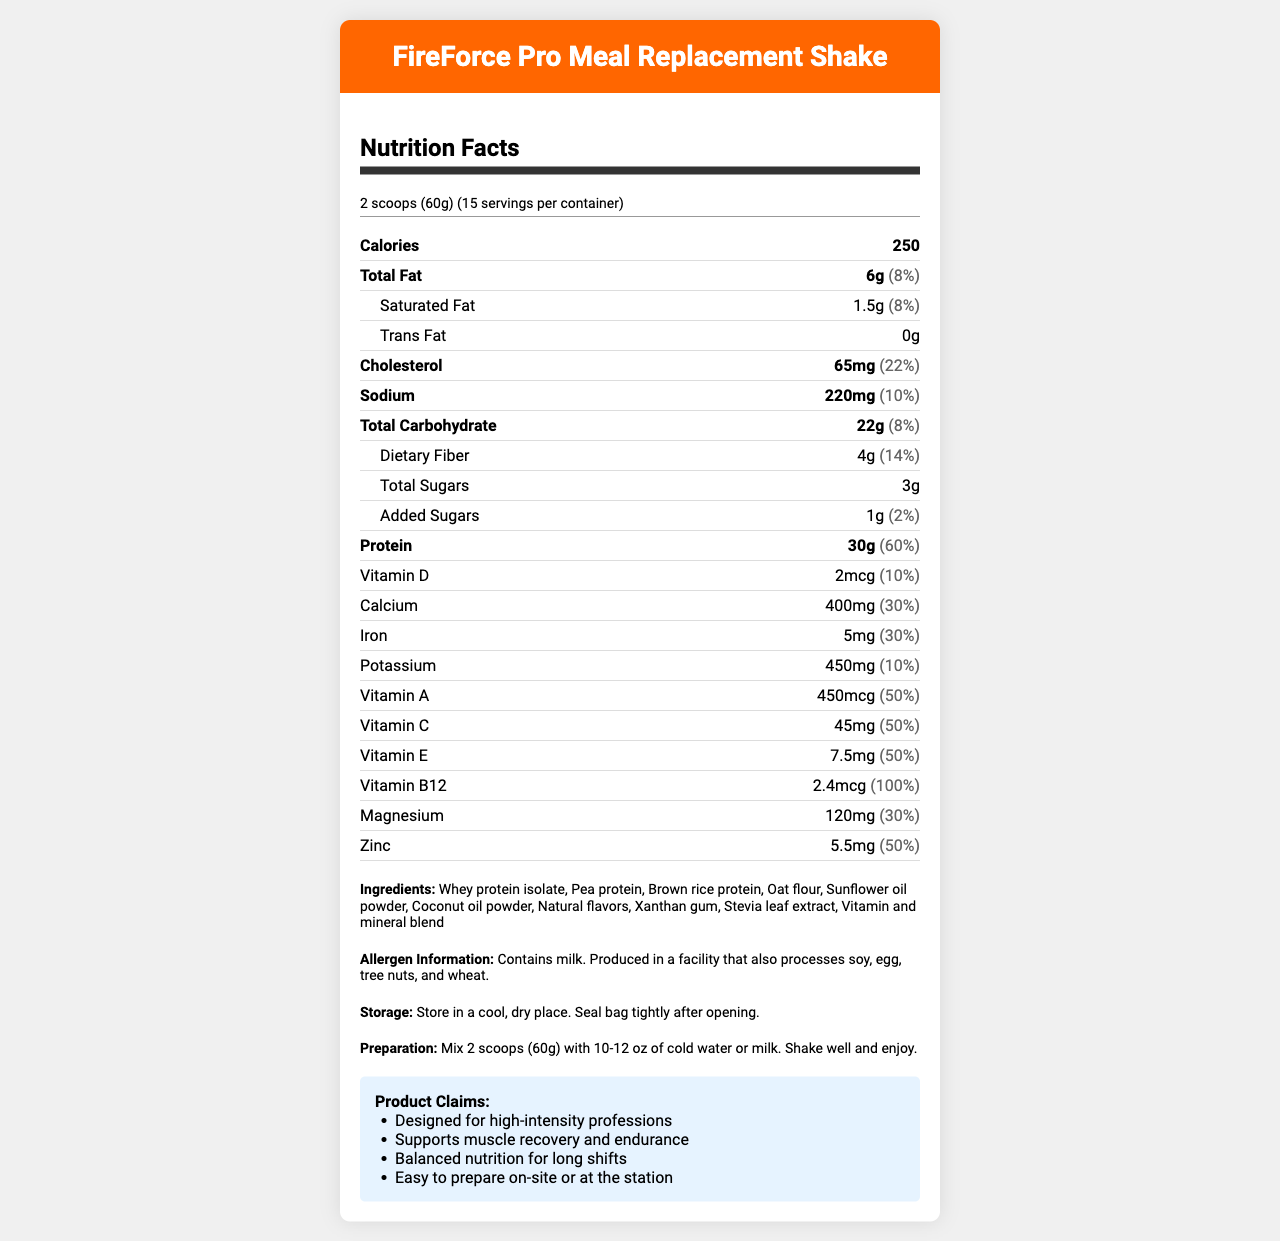What is the product name? The product name is stated at the top of the document, in the header.
Answer: FireForce Pro Meal Replacement Shake What is the serving size for FireForce Pro Meal Replacement Shake? The serving size information is provided under "Nutrition Facts."
Answer: 2 scoops (60g) How many calories are there per serving? The calories per serving are listed in the "Nutrition Facts" section.
Answer: 250 What is the amount of protein per serving? Protein amount is detailed in the "Nutrition Facts" section.
Answer: 30g How much dietary fiber is in each serving? The dietary fiber content is found in the "Nutrition Facts" section.
Answer: 4g What percentage of the daily value of iron is provided per serving? The daily value percentage for iron is indicated in the "Nutrition Facts" section.
Answer: 30% How much cholesterol does one serving contain? Cholesterol content can be found in the "Nutrition Facts" area.
Answer: 65mg Which ingredients in the shake are protein sources? The ingredient list includes Whey protein isolate, Pea protein, and Brown rice protein.
Answer: Whey protein isolate, Pea protein, Brown rice protein What is the daily value percentage for Vitamin B12 in each serving? The daily value for Vitamin B12 is noted under the "Nutrition Facts."
Answer: 100% Where should the FireForce Pro Meal Replacement Shake be stored? Storage instructions are provided towards the end of the document.
Answer: In a cool, dry place. Seal bag tightly after opening. How much added sugar is in each serving? The added sugar amount is stated in the "Nutrition Facts" section.
Answer: 1g Is the product produced in a facility that processes tree nuts? The allergen information mentions that the product is produced in a facility that also processes tree nuts.
Answer: Yes What type of flavors are used in the FireForce Pro Meal Replacement Shake? A. Artificial flavors B. Natural flavors C. Both artificial and natural flavors D. No flavors The ingredient list specifies that natural flavors are used.
Answer: B. Natural flavors Which of the following vitamins is NOT listed in the nutrition facts? I. Vitamin A II. Vitamin B12 III. Vitamin K Vitamin A and Vitamin B12 are in the "Nutrition Facts," but Vitamin K is not.
Answer: III. Vitamin K Does the shake contain any trans fat? The trans fat content is listed as 0g in the "Nutrition Facts."
Answer: No Summarize the main benefits and target audience of FireForce Pro Meal Replacement Shake. The marketing claims highlight the product's suitability for demanding jobs, its support for muscle recovery, balanced nutrition, and easy preparation.
Answer: The FireForce Pro Meal Replacement Shake is designed for high-intensity professions like firefighters and construction workers. It supports muscle recovery and endurance, provides balanced nutrition for long shifts, and is easy to prepare on-site or at the station. How does the protein content in one serving of FireForce Pro Meal Replacement Shake compare to the daily value percentage? The "Nutrition Facts" section shows that 30g of protein corresponds to 60% of the daily value.
Answer: It provides 30g of protein, which is 60% of the daily value. Are any artificial sweeteners used in the FireForce Pro Meal Replacement Shake? The document lists Stevia leaf extract but does not specify whether it is the only sweetener used.
Answer: Cannot be determined What is the total carbohydrate content in one serving? Total carbohydrate content is listed in the "Nutrition Facts."
Answer: 22g What is one of the key benefits mentioned for the FireForce Pro Meal Replacement Shake? A. Supports muscle recovery B. Lowers cholesterol C. Enhances cognitive function D. Reduces stress One of the marketing claims states that the product supports muscle recovery.
Answer: A. Supports muscle recovery Is the product suitable for vegans? The ingredient list includes whey protein isolate, which is derived from milk, making it unsuitable for vegans.
Answer: No How would you prepare the FireForce Pro Meal Replacement Shake? The preparation instructions detail the steps to take to prepare the shake.
Answer: Mix 2 scoops (60g) with 10-12 oz of cold water or milk. Shake well and enjoy. What is the highest percentage daily value for vitamins and minerals listed? A. Vitamin D B. Calcium C. Vitamin B12 D. Zinc Vitamin B12 has the highest daily value percentage at 100%, as indicated in the "Nutrition Facts."
Answer: C. Vitamin B12 